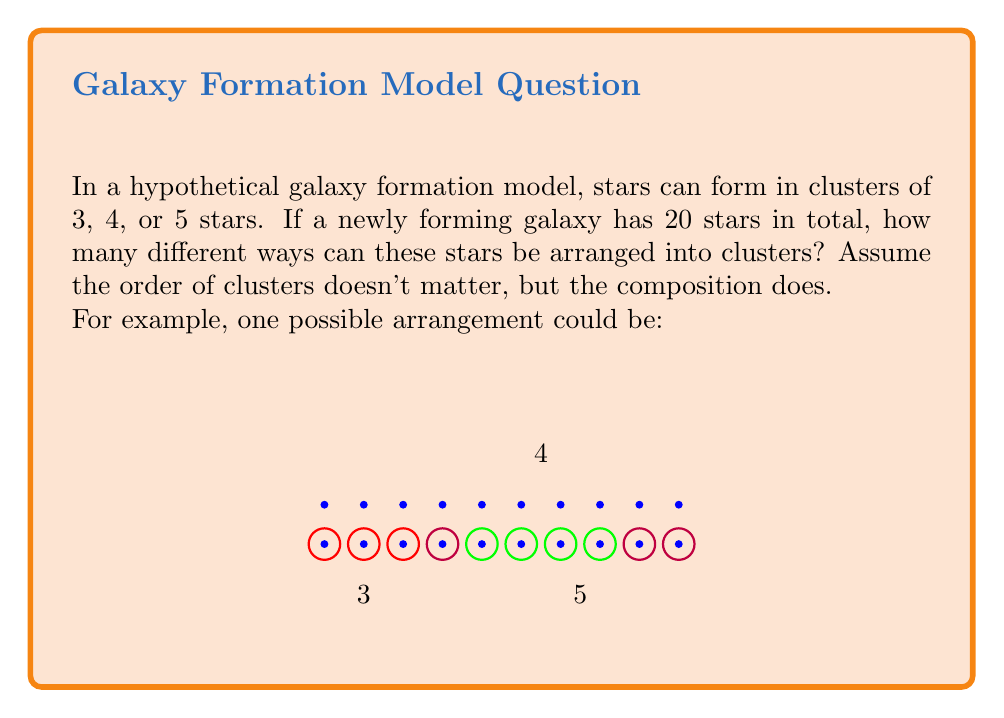Provide a solution to this math problem. To solve this problem, we can use the concept of integer partitions with restrictions. We need to find the number of ways to partition 20 into parts of 3, 4, and 5.

Let's approach this step-by-step:

1) Let $x$, $y$, and $z$ be the number of clusters with 3, 4, and 5 stars respectively.

2) We can form an equation: $3x + 4y + 5z = 20$

3) We need to find all non-negative integer solutions to this equation.

4) We can start by considering the maximum possible value for each variable:
   - Max value of $x$ (when $y=z=0$): $\lfloor 20/3 \rfloor = 6$
   - Max value of $y$ (when $x=z=0$): $\lfloor 20/4 \rfloor = 5$
   - Max value of $z$ (when $x=y=0$): $\lfloor 20/5 \rfloor = 4$

5) Now, let's list all possible combinations:
   - $z=4$, $x=0$, $y=0$
   - $z=3$, $x=1$, $y=1$
   - $z=2$, $x=2$, $y=2$
   - $z=2$, $x=4$, $y=0$
   - $z=1$, $x=5$, $y=1$
   - $z=1$, $x=3$, $y=3$
   - $z=1$, $x=1$, $y=4$
   - $z=0$, $x=4$, $y=2$
   - $z=0$, $x=2$, $y=3$
   - $z=0$, $x=0$, $y=5$

6) Counting these combinations, we find that there are 10 different ways to arrange 20 stars into clusters of 3, 4, or 5.

This problem demonstrates how combinatorial analysis can be applied to star formation patterns, providing a simplified model of how stars might cluster in a forming galaxy.
Answer: 10 